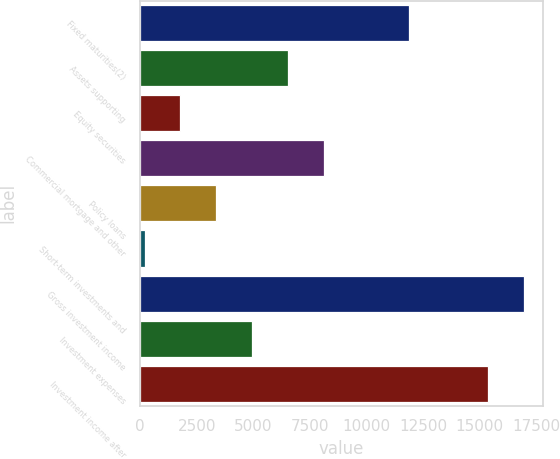Convert chart to OTSL. <chart><loc_0><loc_0><loc_500><loc_500><bar_chart><fcel>Fixed maturities(2)<fcel>Assets supporting<fcel>Equity securities<fcel>Commercial mortgage and other<fcel>Policy loans<fcel>Short-term investments and<fcel>Gross investment income<fcel>Investment expenses<fcel>Investment income after<nl><fcel>11858<fcel>6531.8<fcel>1780.7<fcel>8115.5<fcel>3364.4<fcel>197<fcel>16950.7<fcel>4948.1<fcel>15367<nl></chart> 